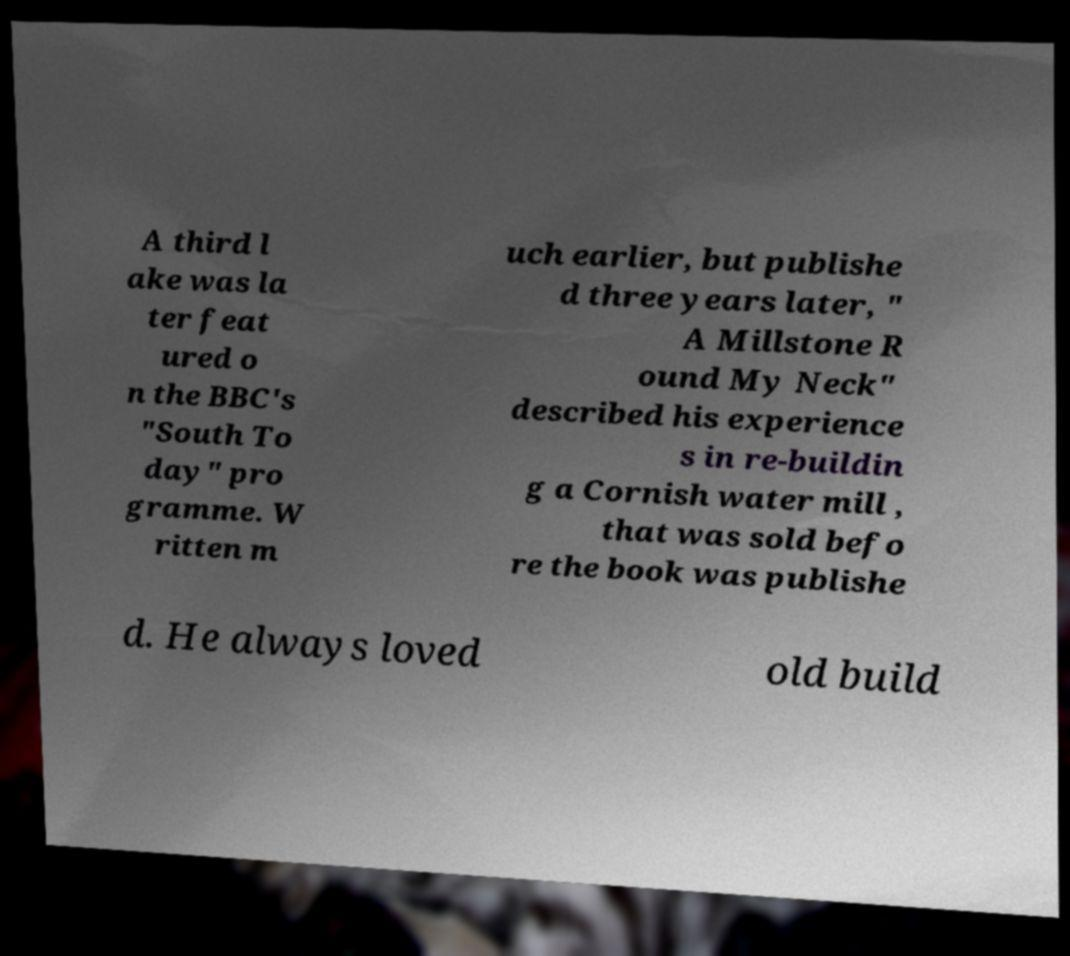What messages or text are displayed in this image? I need them in a readable, typed format. A third l ake was la ter feat ured o n the BBC's "South To day" pro gramme. W ritten m uch earlier, but publishe d three years later, " A Millstone R ound My Neck" described his experience s in re-buildin g a Cornish water mill , that was sold befo re the book was publishe d. He always loved old build 